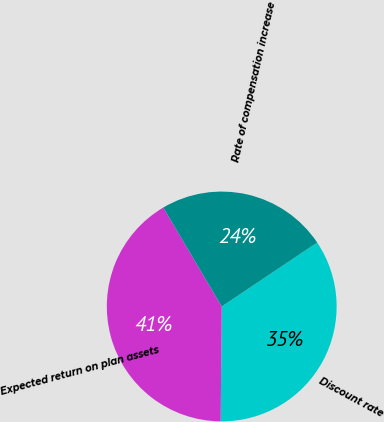Convert chart to OTSL. <chart><loc_0><loc_0><loc_500><loc_500><pie_chart><fcel>Discount rate<fcel>Expected return on plan assets<fcel>Rate of compensation increase<nl><fcel>34.54%<fcel>41.37%<fcel>24.1%<nl></chart> 